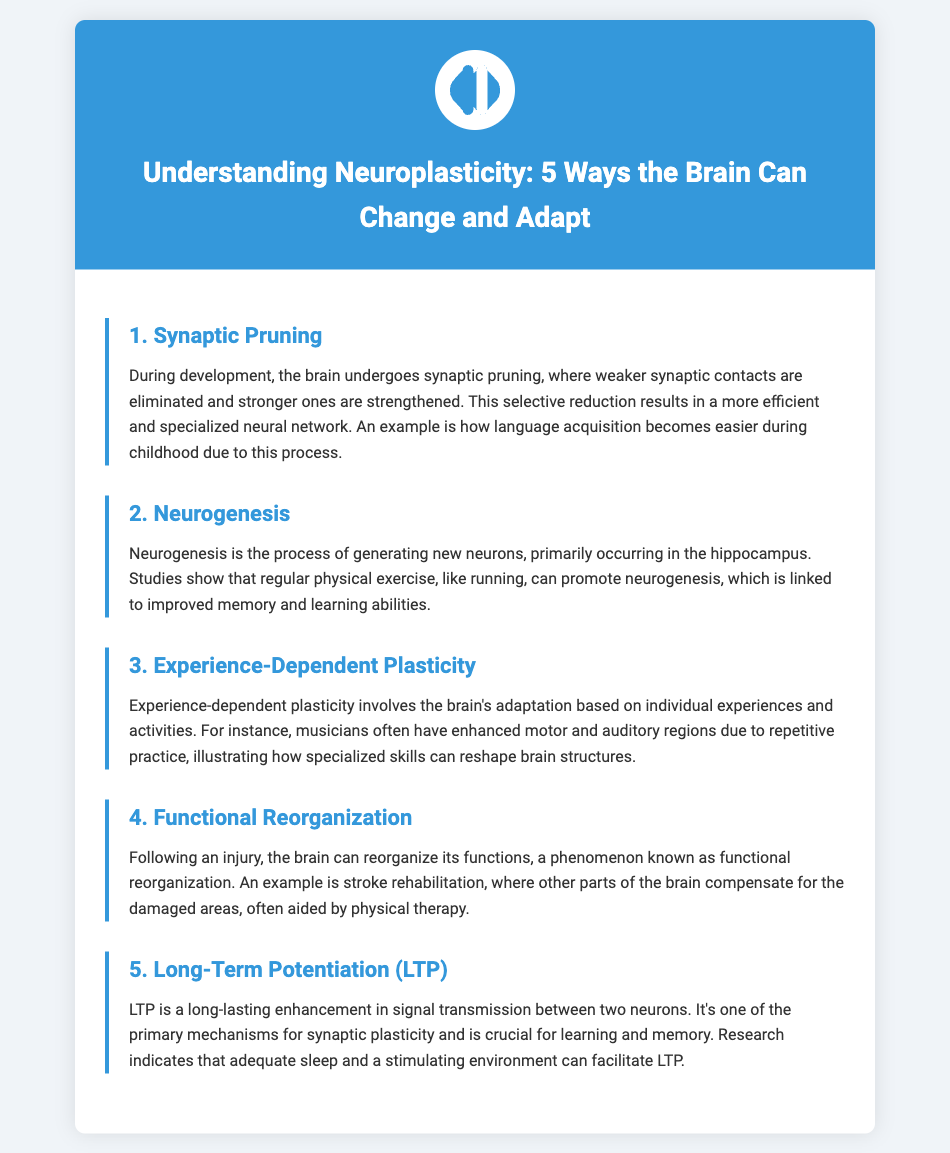What is synaptic pruning? Synaptic pruning is the process where weaker synaptic contacts are eliminated and stronger ones are strengthened to result in a more efficient neural network.
Answer: The process where weaker synaptic contacts are eliminated What does neurogenesis promote? Neurogenesis promotes the generation of new neurons, which is linked to improved memory and learning abilities.
Answer: Improved memory and learning abilities Which region of the brain is primarily associated with neurogenesis? The document states that neurogenesis primarily occurs in the hippocampus.
Answer: Hippocampus What is functional reorganization? Functional reorganization is the phenomenon where the brain can adapt its functions following an injury, compensating for damaged areas.
Answer: The brain adapts its functions following an injury What is one key mechanism for learning and memory mentioned in the document? The document identifies long-term potentiation (LTP) as the primary mechanism for synaptic plasticity related to learning and memory.
Answer: Long-term potentiation (LTP) How can experience-dependent plasticity be illustrated? Experience-dependent plasticity is illustrated by musicians having enhanced motor and auditory regions from repetitive practice.
Answer: Musicians enhanced motor and auditory regions What can facilitate long-term potentiation (LTP)? Adequate sleep and a stimulating environment can facilitate LTP, according to the document.
Answer: Adequate sleep and a stimulating environment How many ways the brain can change and adapt are listed? The document lists a total of five ways the brain can change and adapt.
Answer: Five ways In what context is synaptic pruning particularly relevant? The context relevant for synaptic pruning is language acquisition during childhood.
Answer: Language acquisition during childhood 